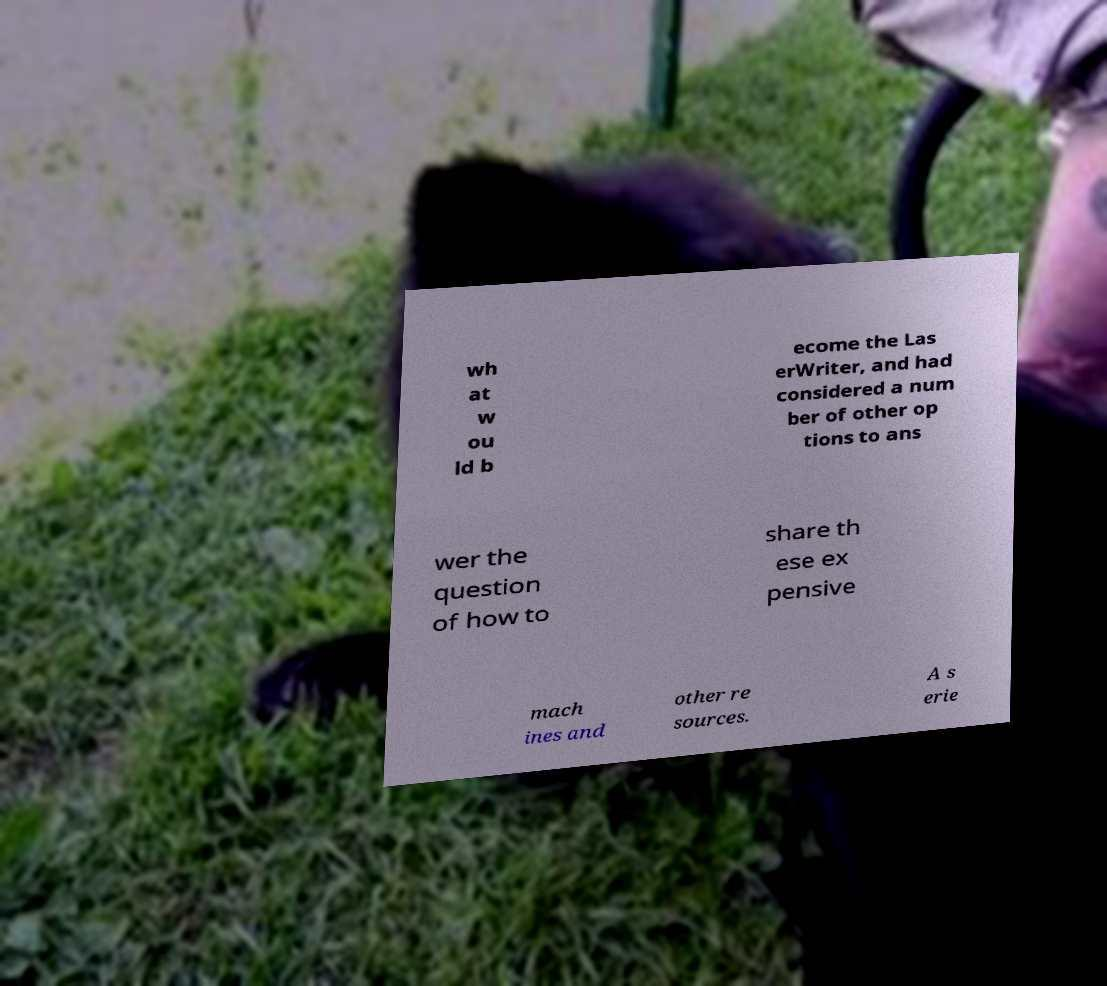Could you extract and type out the text from this image? wh at w ou ld b ecome the Las erWriter, and had considered a num ber of other op tions to ans wer the question of how to share th ese ex pensive mach ines and other re sources. A s erie 